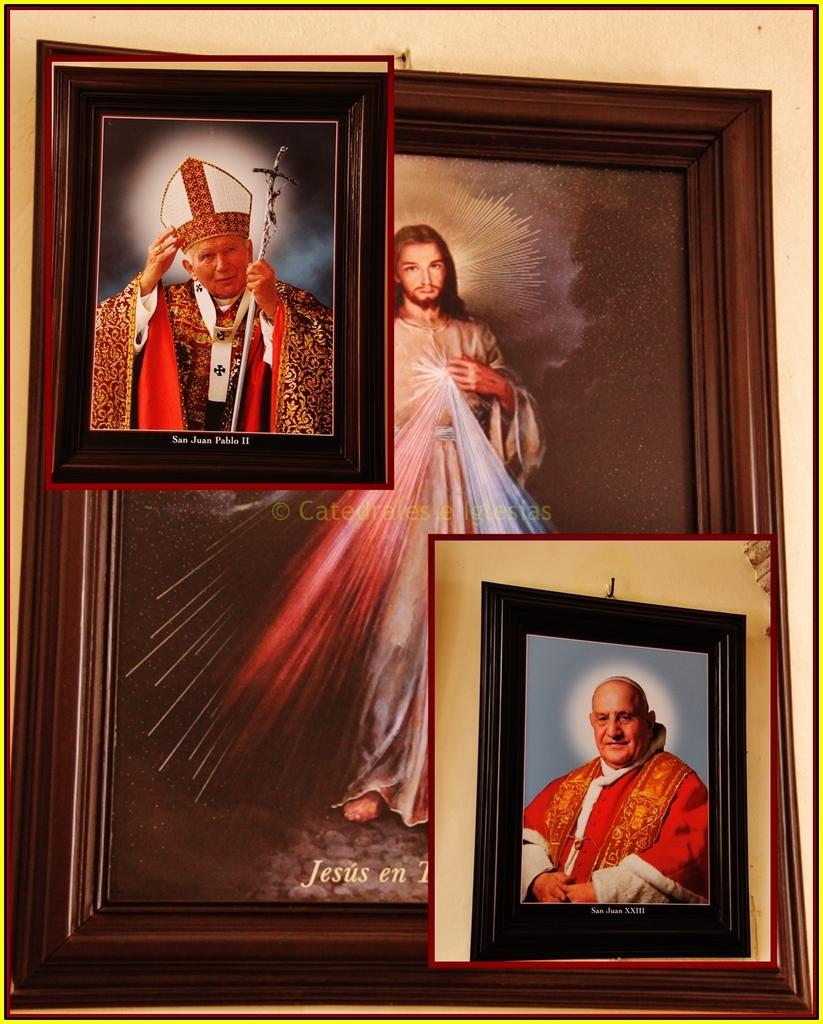Who is this a picture of?
Give a very brief answer. Jesus. 